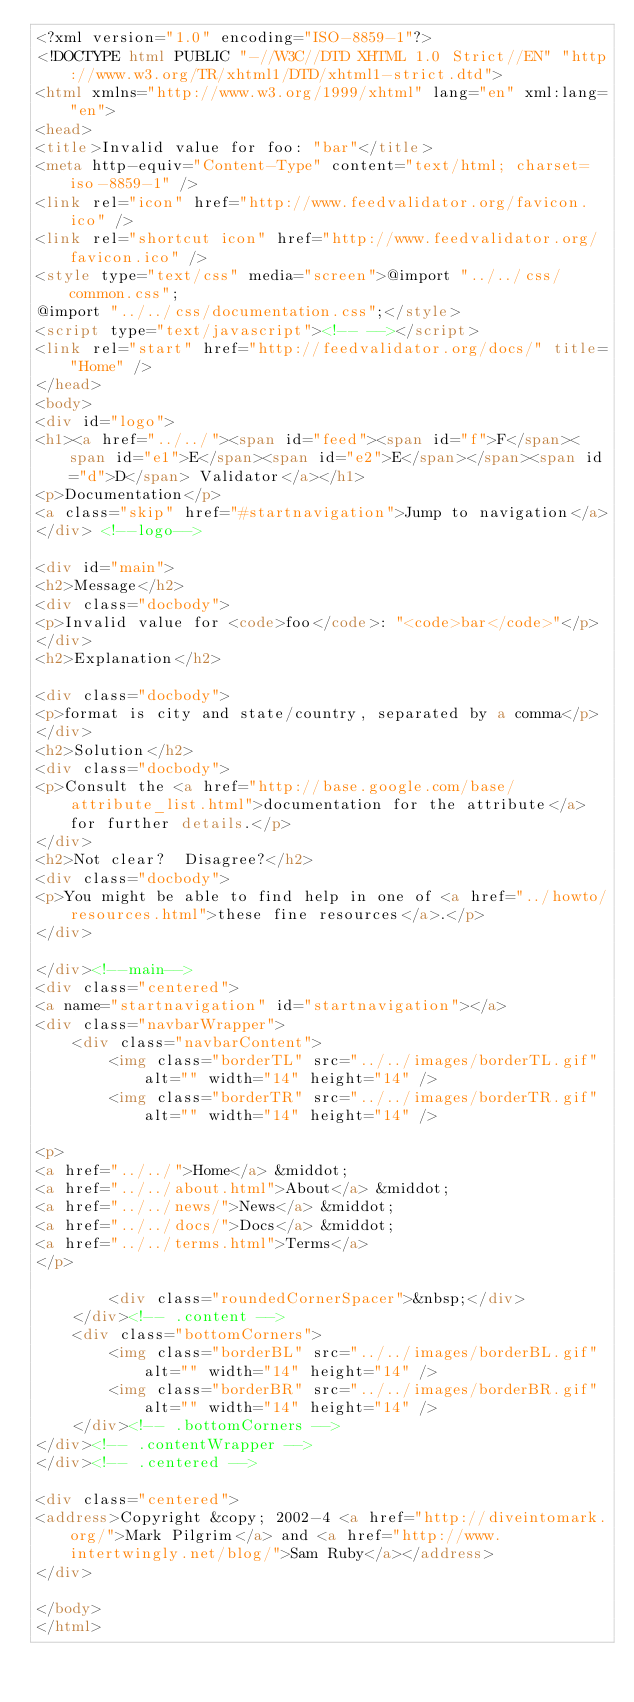<code> <loc_0><loc_0><loc_500><loc_500><_HTML_><?xml version="1.0" encoding="ISO-8859-1"?>
<!DOCTYPE html PUBLIC "-//W3C//DTD XHTML 1.0 Strict//EN" "http://www.w3.org/TR/xhtml1/DTD/xhtml1-strict.dtd">
<html xmlns="http://www.w3.org/1999/xhtml" lang="en" xml:lang="en">
<head>
<title>Invalid value for foo: "bar"</title>
<meta http-equiv="Content-Type" content="text/html; charset=iso-8859-1" />
<link rel="icon" href="http://www.feedvalidator.org/favicon.ico" />
<link rel="shortcut icon" href="http://www.feedvalidator.org/favicon.ico" />
<style type="text/css" media="screen">@import "../../css/common.css";
@import "../../css/documentation.css";</style>
<script type="text/javascript"><!-- --></script>
<link rel="start" href="http://feedvalidator.org/docs/" title="Home" />
</head>
<body>
<div id="logo">
<h1><a href="../../"><span id="feed"><span id="f">F</span><span id="e1">E</span><span id="e2">E</span></span><span id="d">D</span> Validator</a></h1>
<p>Documentation</p>
<a class="skip" href="#startnavigation">Jump to navigation</a>
</div> <!--logo-->

<div id="main">
<h2>Message</h2>
<div class="docbody">
<p>Invalid value for <code>foo</code>: "<code>bar</code>"</p>
</div>
<h2>Explanation</h2>

<div class="docbody">
<p>format is city and state/country, separated by a comma</p>
</div>
<h2>Solution</h2>
<div class="docbody">
<p>Consult the <a href="http://base.google.com/base/attribute_list.html">documentation for the attribute</a> for further details.</p>
</div>
<h2>Not clear?  Disagree?</h2>
<div class="docbody">
<p>You might be able to find help in one of <a href="../howto/resources.html">these fine resources</a>.</p>
</div>

</div><!--main-->
<div class="centered">
<a name="startnavigation" id="startnavigation"></a>
<div class="navbarWrapper">
    <div class="navbarContent">
        <img class="borderTL" src="../../images/borderTL.gif" alt="" width="14" height="14" />
        <img class="borderTR" src="../../images/borderTR.gif" alt="" width="14" height="14" />

<p>
<a href="../../">Home</a> &middot;
<a href="../../about.html">About</a> &middot;
<a href="../../news/">News</a> &middot;
<a href="../../docs/">Docs</a> &middot;
<a href="../../terms.html">Terms</a>
</p>

        <div class="roundedCornerSpacer">&nbsp;</div>
    </div><!-- .content -->
    <div class="bottomCorners">
        <img class="borderBL" src="../../images/borderBL.gif" alt="" width="14" height="14" />
        <img class="borderBR" src="../../images/borderBR.gif" alt="" width="14" height="14" />
    </div><!-- .bottomCorners -->
</div><!-- .contentWrapper -->
</div><!-- .centered -->

<div class="centered">
<address>Copyright &copy; 2002-4 <a href="http://diveintomark.org/">Mark Pilgrim</a> and <a href="http://www.intertwingly.net/blog/">Sam Ruby</a></address>
</div>

</body>
</html>
</code> 